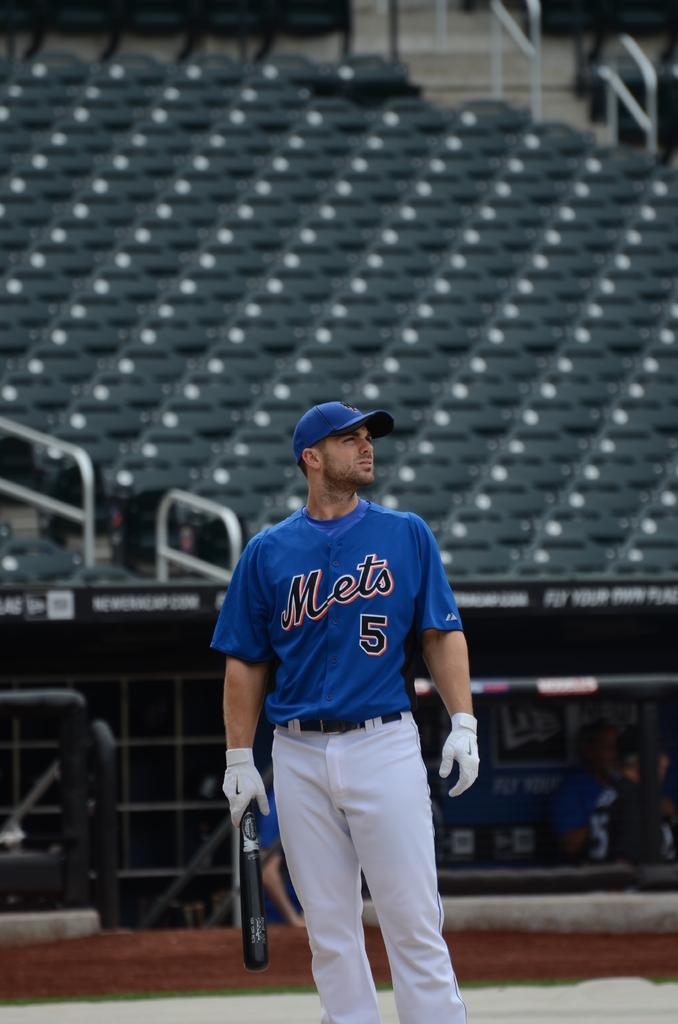<image>
Present a compact description of the photo's key features. a Mets 5 player waiting to bat on the field 